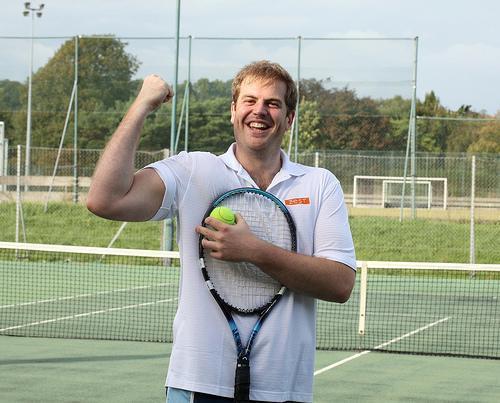How many people are in the photo?
Give a very brief answer. 1. 